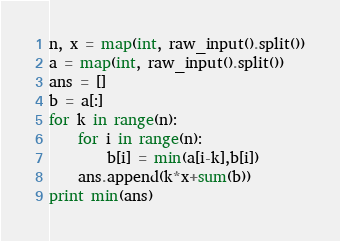Convert code to text. <code><loc_0><loc_0><loc_500><loc_500><_Python_>n, x = map(int, raw_input().split())
a = map(int, raw_input().split())
ans = []
b = a[:]
for k in range(n):
    for i in range(n):
        b[i] = min(a[i-k],b[i])
    ans.append(k*x+sum(b))
print min(ans)
</code> 